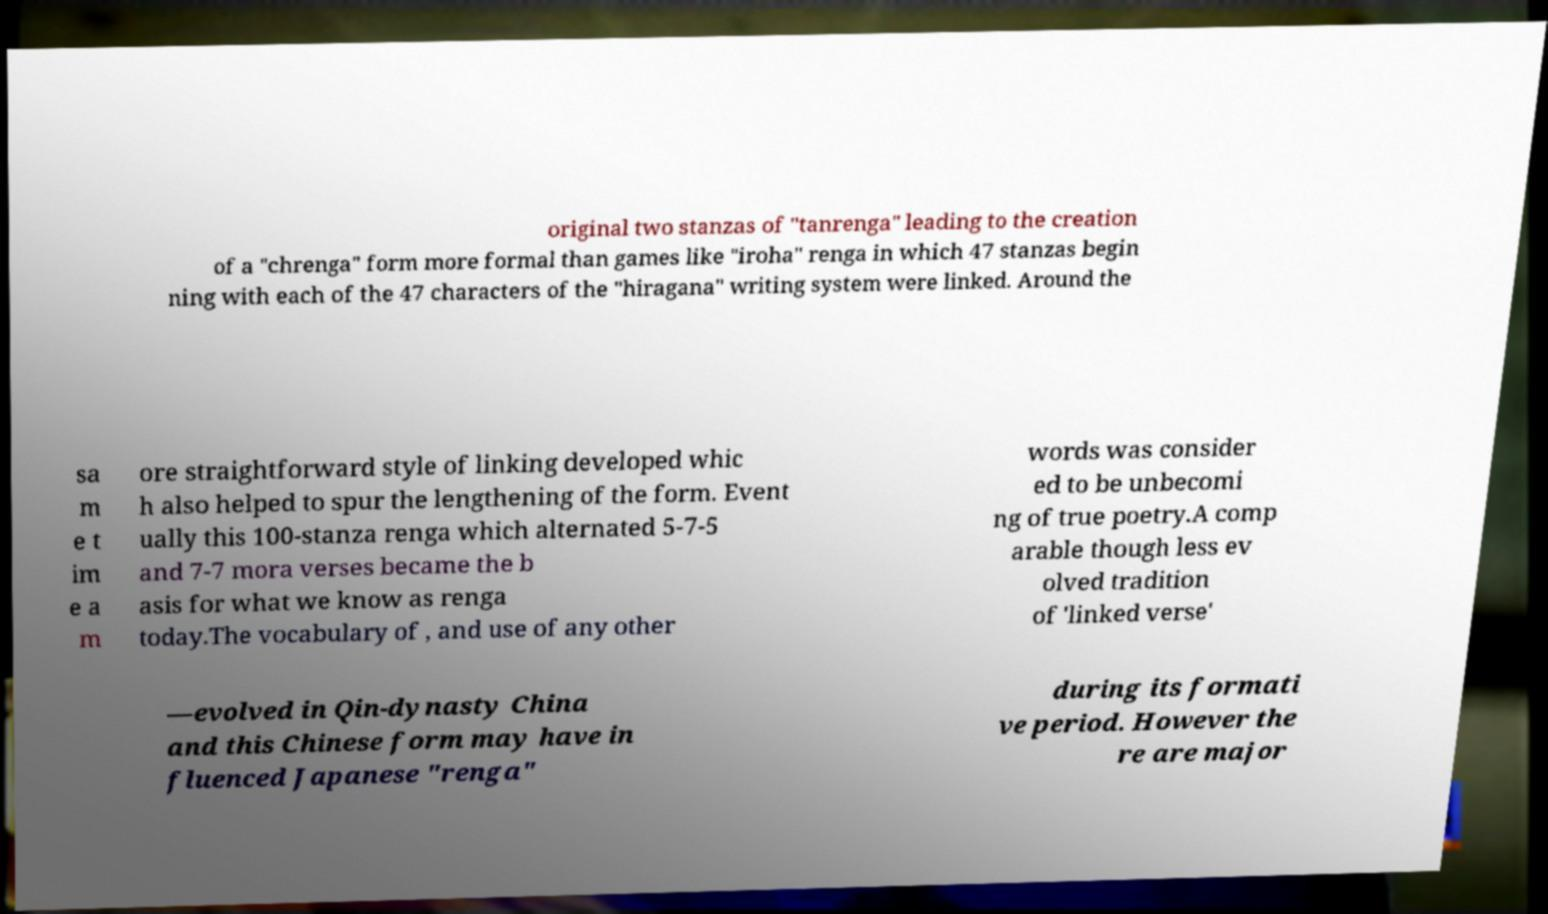Could you assist in decoding the text presented in this image and type it out clearly? original two stanzas of "tanrenga" leading to the creation of a "chrenga" form more formal than games like "iroha" renga in which 47 stanzas begin ning with each of the 47 characters of the "hiragana" writing system were linked. Around the sa m e t im e a m ore straightforward style of linking developed whic h also helped to spur the lengthening of the form. Event ually this 100-stanza renga which alternated 5-7-5 and 7-7 mora verses became the b asis for what we know as renga today.The vocabulary of , and use of any other words was consider ed to be unbecomi ng of true poetry.A comp arable though less ev olved tradition of 'linked verse' —evolved in Qin-dynasty China and this Chinese form may have in fluenced Japanese "renga" during its formati ve period. However the re are major 